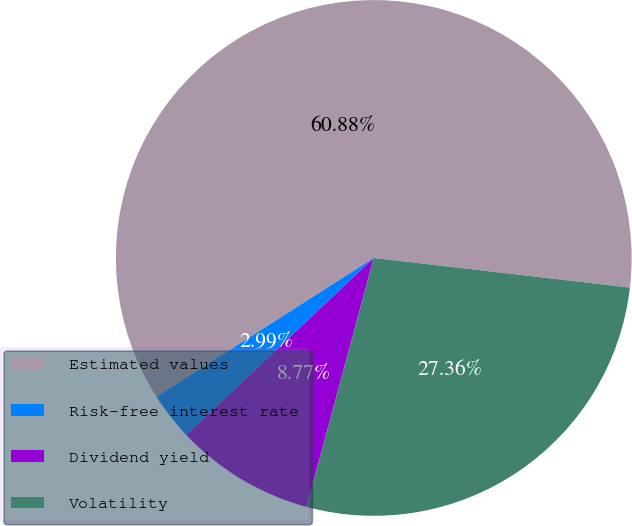Convert chart. <chart><loc_0><loc_0><loc_500><loc_500><pie_chart><fcel>Estimated values<fcel>Risk-free interest rate<fcel>Dividend yield<fcel>Volatility<nl><fcel>60.88%<fcel>2.99%<fcel>8.77%<fcel>27.36%<nl></chart> 